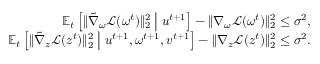<formula> <loc_0><loc_0><loc_500><loc_500>\begin{array} { r } { \mathbb { E } _ { t } \left [ \| \tilde { \nabla } _ { \omega } \mathcal { L } ( \omega ^ { t } ) \| _ { 2 } ^ { 2 } \, | d l e | \, u ^ { t + 1 } \right ] - \| \nabla _ { \omega } \mathcal { L } ( \omega ^ { t } ) \| _ { 2 } ^ { 2 } \leq \sigma ^ { 2 } , } \\ { \mathbb { E } _ { t } \left [ \| \tilde { \nabla } _ { z } \mathcal { L } ( z ^ { t } ) \| _ { 2 } ^ { 2 } \, | d l e | \, u ^ { t + 1 } , \omega ^ { t + 1 } , v ^ { t + 1 } \right ] - \| \nabla _ { z } \mathcal { L } ( z ^ { t } ) \| _ { 2 } ^ { 2 } \leq \sigma ^ { 2 } . } \end{array}</formula> 